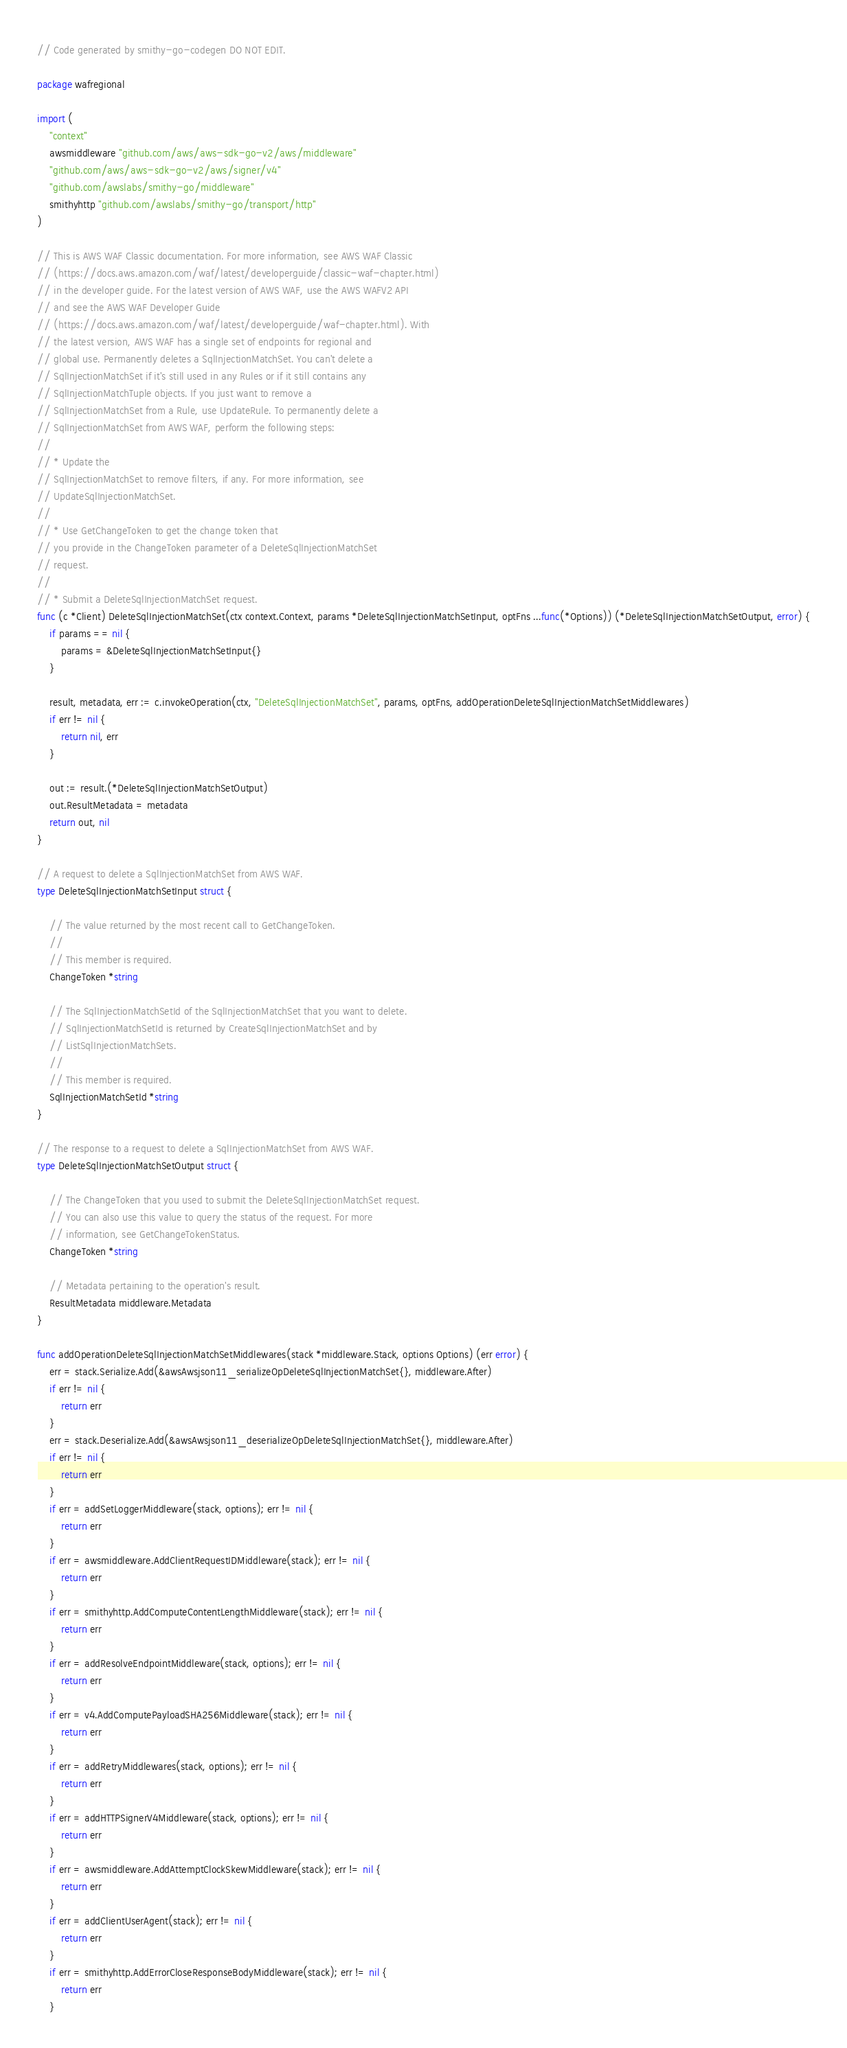<code> <loc_0><loc_0><loc_500><loc_500><_Go_>// Code generated by smithy-go-codegen DO NOT EDIT.

package wafregional

import (
	"context"
	awsmiddleware "github.com/aws/aws-sdk-go-v2/aws/middleware"
	"github.com/aws/aws-sdk-go-v2/aws/signer/v4"
	"github.com/awslabs/smithy-go/middleware"
	smithyhttp "github.com/awslabs/smithy-go/transport/http"
)

// This is AWS WAF Classic documentation. For more information, see AWS WAF Classic
// (https://docs.aws.amazon.com/waf/latest/developerguide/classic-waf-chapter.html)
// in the developer guide. For the latest version of AWS WAF, use the AWS WAFV2 API
// and see the AWS WAF Developer Guide
// (https://docs.aws.amazon.com/waf/latest/developerguide/waf-chapter.html). With
// the latest version, AWS WAF has a single set of endpoints for regional and
// global use. Permanently deletes a SqlInjectionMatchSet. You can't delete a
// SqlInjectionMatchSet if it's still used in any Rules or if it still contains any
// SqlInjectionMatchTuple objects. If you just want to remove a
// SqlInjectionMatchSet from a Rule, use UpdateRule. To permanently delete a
// SqlInjectionMatchSet from AWS WAF, perform the following steps:
//
// * Update the
// SqlInjectionMatchSet to remove filters, if any. For more information, see
// UpdateSqlInjectionMatchSet.
//
// * Use GetChangeToken to get the change token that
// you provide in the ChangeToken parameter of a DeleteSqlInjectionMatchSet
// request.
//
// * Submit a DeleteSqlInjectionMatchSet request.
func (c *Client) DeleteSqlInjectionMatchSet(ctx context.Context, params *DeleteSqlInjectionMatchSetInput, optFns ...func(*Options)) (*DeleteSqlInjectionMatchSetOutput, error) {
	if params == nil {
		params = &DeleteSqlInjectionMatchSetInput{}
	}

	result, metadata, err := c.invokeOperation(ctx, "DeleteSqlInjectionMatchSet", params, optFns, addOperationDeleteSqlInjectionMatchSetMiddlewares)
	if err != nil {
		return nil, err
	}

	out := result.(*DeleteSqlInjectionMatchSetOutput)
	out.ResultMetadata = metadata
	return out, nil
}

// A request to delete a SqlInjectionMatchSet from AWS WAF.
type DeleteSqlInjectionMatchSetInput struct {

	// The value returned by the most recent call to GetChangeToken.
	//
	// This member is required.
	ChangeToken *string

	// The SqlInjectionMatchSetId of the SqlInjectionMatchSet that you want to delete.
	// SqlInjectionMatchSetId is returned by CreateSqlInjectionMatchSet and by
	// ListSqlInjectionMatchSets.
	//
	// This member is required.
	SqlInjectionMatchSetId *string
}

// The response to a request to delete a SqlInjectionMatchSet from AWS WAF.
type DeleteSqlInjectionMatchSetOutput struct {

	// The ChangeToken that you used to submit the DeleteSqlInjectionMatchSet request.
	// You can also use this value to query the status of the request. For more
	// information, see GetChangeTokenStatus.
	ChangeToken *string

	// Metadata pertaining to the operation's result.
	ResultMetadata middleware.Metadata
}

func addOperationDeleteSqlInjectionMatchSetMiddlewares(stack *middleware.Stack, options Options) (err error) {
	err = stack.Serialize.Add(&awsAwsjson11_serializeOpDeleteSqlInjectionMatchSet{}, middleware.After)
	if err != nil {
		return err
	}
	err = stack.Deserialize.Add(&awsAwsjson11_deserializeOpDeleteSqlInjectionMatchSet{}, middleware.After)
	if err != nil {
		return err
	}
	if err = addSetLoggerMiddleware(stack, options); err != nil {
		return err
	}
	if err = awsmiddleware.AddClientRequestIDMiddleware(stack); err != nil {
		return err
	}
	if err = smithyhttp.AddComputeContentLengthMiddleware(stack); err != nil {
		return err
	}
	if err = addResolveEndpointMiddleware(stack, options); err != nil {
		return err
	}
	if err = v4.AddComputePayloadSHA256Middleware(stack); err != nil {
		return err
	}
	if err = addRetryMiddlewares(stack, options); err != nil {
		return err
	}
	if err = addHTTPSignerV4Middleware(stack, options); err != nil {
		return err
	}
	if err = awsmiddleware.AddAttemptClockSkewMiddleware(stack); err != nil {
		return err
	}
	if err = addClientUserAgent(stack); err != nil {
		return err
	}
	if err = smithyhttp.AddErrorCloseResponseBodyMiddleware(stack); err != nil {
		return err
	}</code> 